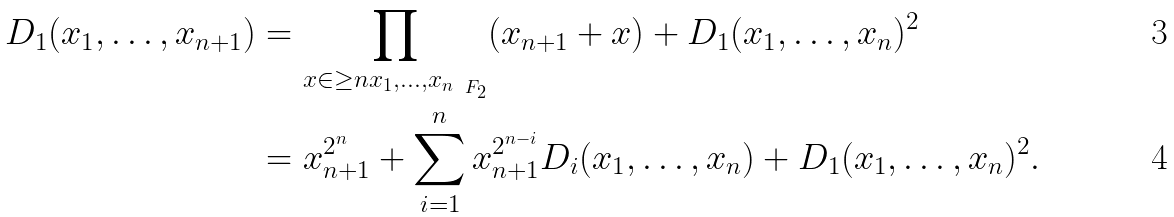Convert formula to latex. <formula><loc_0><loc_0><loc_500><loc_500>D _ { 1 } ( x _ { 1 } , \dots , x _ { n + 1 } ) & = \prod _ { x \in \geq n { x _ { 1 } , \dots , x _ { n } } _ { \ F _ { 2 } } } ( x _ { n + 1 } + x ) + D _ { 1 } ( x _ { 1 } , \dots , x _ { n } ) ^ { 2 } \\ & = x _ { n + 1 } ^ { 2 ^ { n } } + \sum _ { i = 1 } ^ { n } x _ { n + 1 } ^ { 2 ^ { n - i } } D _ { i } ( x _ { 1 } , \dots , x _ { n } ) + D _ { 1 } ( x _ { 1 } , \dots , x _ { n } ) ^ { 2 } .</formula> 